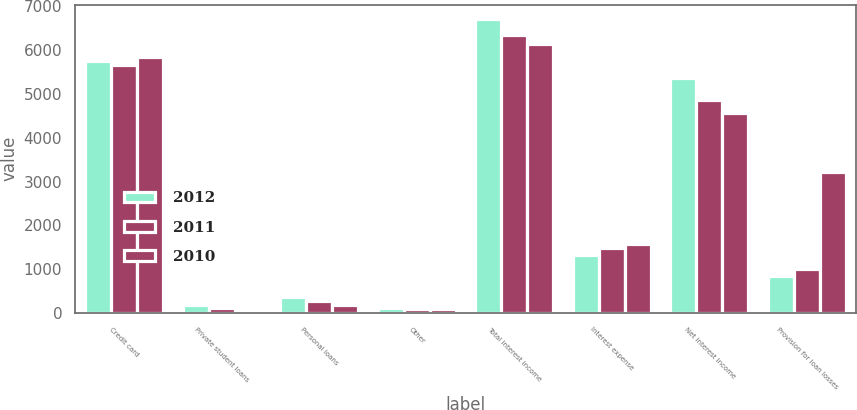Convert chart to OTSL. <chart><loc_0><loc_0><loc_500><loc_500><stacked_bar_chart><ecel><fcel>Credit card<fcel>Private student loans<fcel>Personal loans<fcel>Other<fcel>Total interest income<fcel>Interest expense<fcel>Net interest income<fcel>Provision for loan losses<nl><fcel>2012<fcel>5751<fcel>184<fcel>363<fcel>102<fcel>6703<fcel>1331<fcel>5372<fcel>848<nl><fcel>2011<fcel>5654<fcel>115<fcel>266<fcel>85<fcel>6345<fcel>1485<fcel>4860<fcel>1013<nl><fcel>2010<fcel>5836<fcel>48<fcel>182<fcel>80<fcel>6146<fcel>1583<fcel>4563<fcel>3207<nl></chart> 